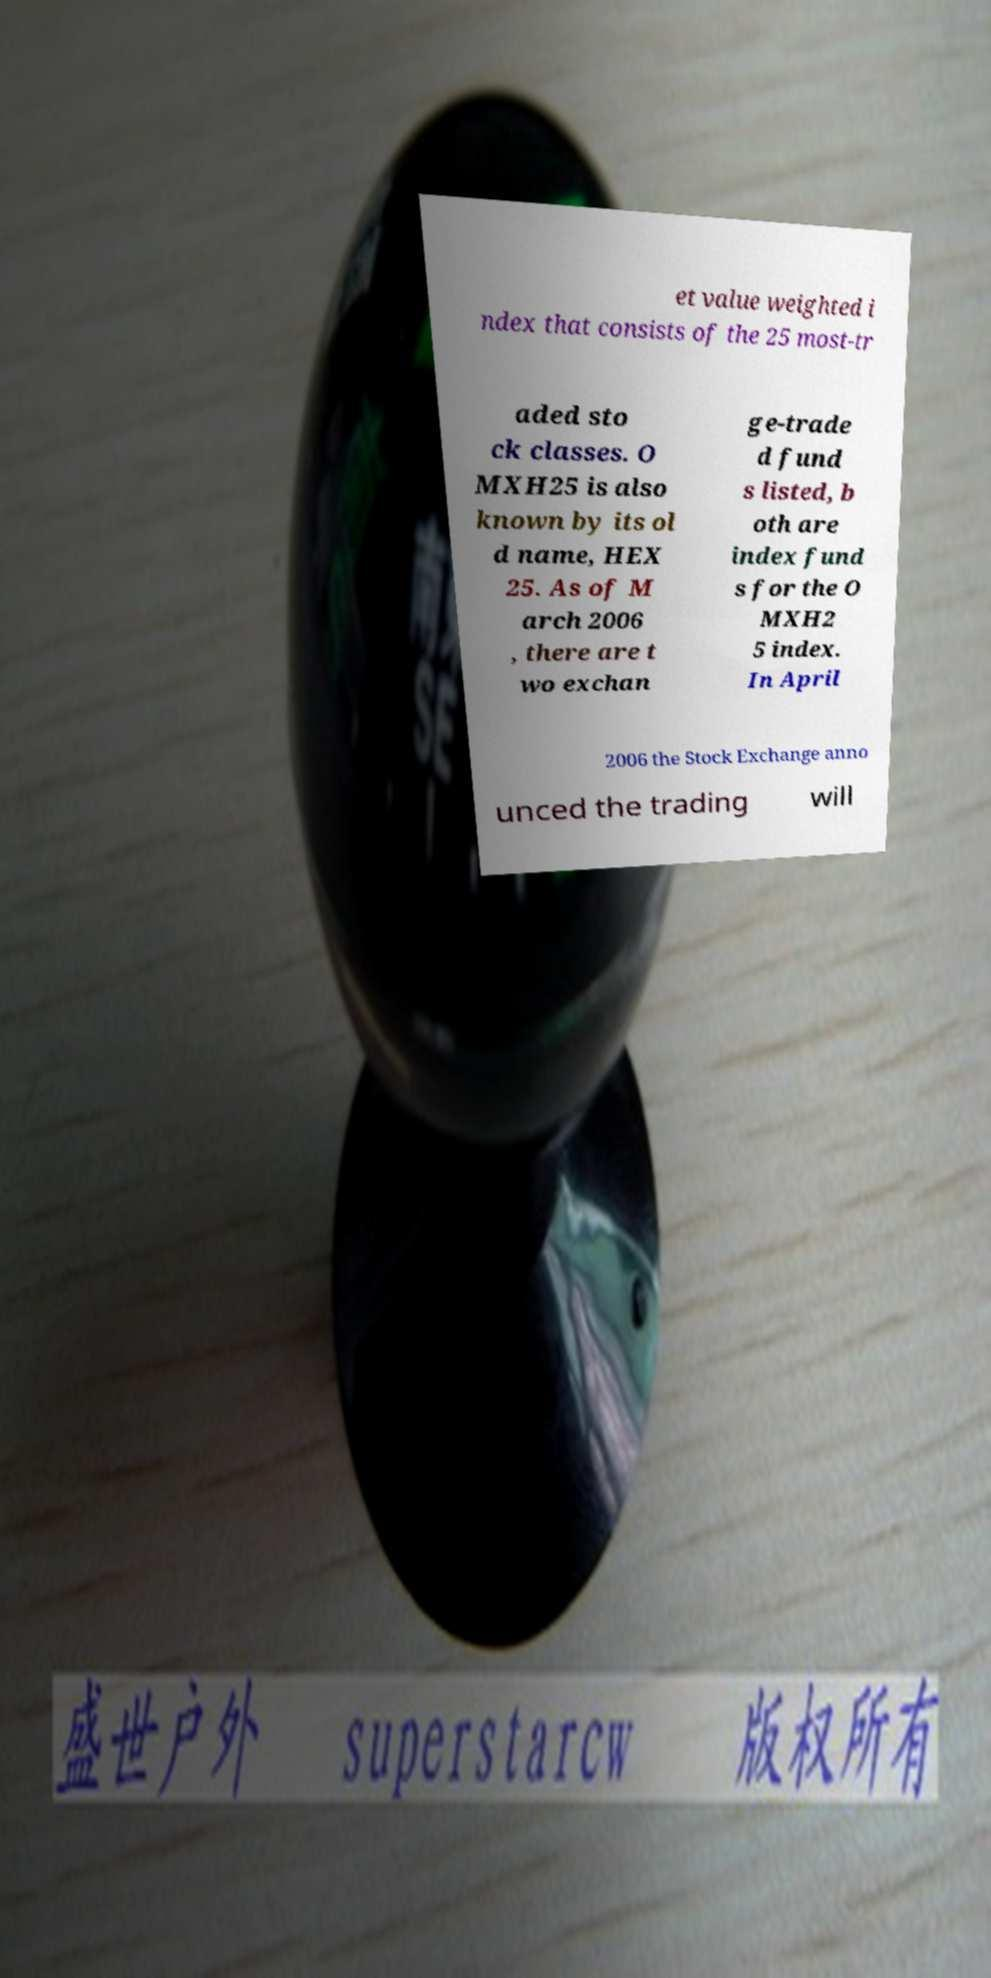Could you extract and type out the text from this image? et value weighted i ndex that consists of the 25 most-tr aded sto ck classes. O MXH25 is also known by its ol d name, HEX 25. As of M arch 2006 , there are t wo exchan ge-trade d fund s listed, b oth are index fund s for the O MXH2 5 index. In April 2006 the Stock Exchange anno unced the trading will 